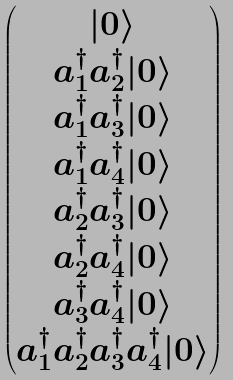Convert formula to latex. <formula><loc_0><loc_0><loc_500><loc_500>\begin{pmatrix} | 0 \rangle \\ a ^ { \dagger } _ { 1 } a ^ { \dagger } _ { 2 } | 0 \rangle \\ a ^ { \dagger } _ { 1 } a ^ { \dagger } _ { 3 } | 0 \rangle \\ a ^ { \dagger } _ { 1 } a ^ { \dagger } _ { 4 } | 0 \rangle \\ a ^ { \dagger } _ { 2 } a ^ { \dagger } _ { 3 } | 0 \rangle \\ a ^ { \dagger } _ { 2 } a ^ { \dagger } _ { 4 } | 0 \rangle \\ a ^ { \dagger } _ { 3 } a ^ { \dagger } _ { 4 } | 0 \rangle \\ a ^ { \dagger } _ { 1 } a ^ { \dagger } _ { 2 } a ^ { \dagger } _ { 3 } a ^ { \dagger } _ { 4 } | 0 \rangle \end{pmatrix}</formula> 